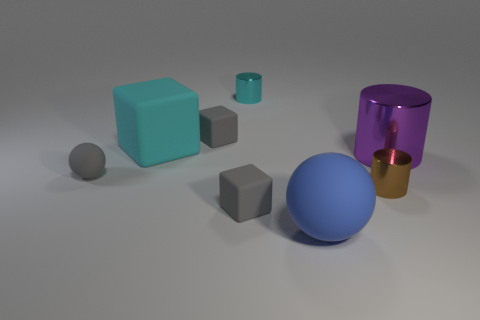Is there a small thing that is to the left of the tiny metal cylinder behind the big cyan matte cube?
Provide a short and direct response. Yes. Do the gray matte ball and the cylinder on the right side of the small brown metal cylinder have the same size?
Offer a very short reply. No. There is a rubber sphere that is behind the blue ball to the right of the cyan matte cube; are there any shiny cylinders that are behind it?
Make the answer very short. Yes. What is the tiny cylinder that is to the right of the small cyan cylinder made of?
Keep it short and to the point. Metal. Is the cyan matte block the same size as the cyan cylinder?
Your answer should be compact. No. There is a tiny matte object that is in front of the big metallic object and right of the gray matte sphere; what is its color?
Provide a short and direct response. Gray. What is the shape of the cyan object that is the same material as the big cylinder?
Offer a terse response. Cylinder. How many small objects are behind the large cyan rubber thing and in front of the small cyan metallic cylinder?
Make the answer very short. 1. Are there any large cyan cubes on the left side of the purple cylinder?
Offer a very short reply. Yes. Do the metallic thing in front of the large purple metal thing and the large thing in front of the gray rubber ball have the same shape?
Provide a short and direct response. No. 